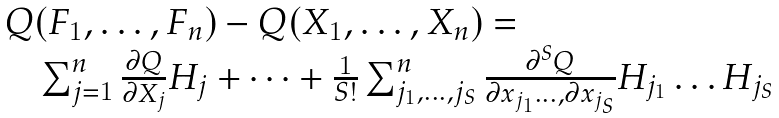Convert formula to latex. <formula><loc_0><loc_0><loc_500><loc_500>\begin{array} { l } Q ( F _ { 1 } , \dots , F _ { n } ) - Q ( X _ { 1 } , \dots , X _ { n } ) = \\ \quad \sum _ { j = 1 } ^ { n } \frac { \partial Q } { \partial X _ { j } } H _ { j } + \dots + \frac { 1 } { S ! } \sum _ { j _ { 1 } , \dots , j _ { S } } ^ { n } \frac { \partial ^ { S } Q } { \partial x _ { j _ { 1 } } \dots , \partial x _ { j _ { S } } } H _ { j _ { 1 } } \dots H _ { j _ { S } } \end{array}</formula> 